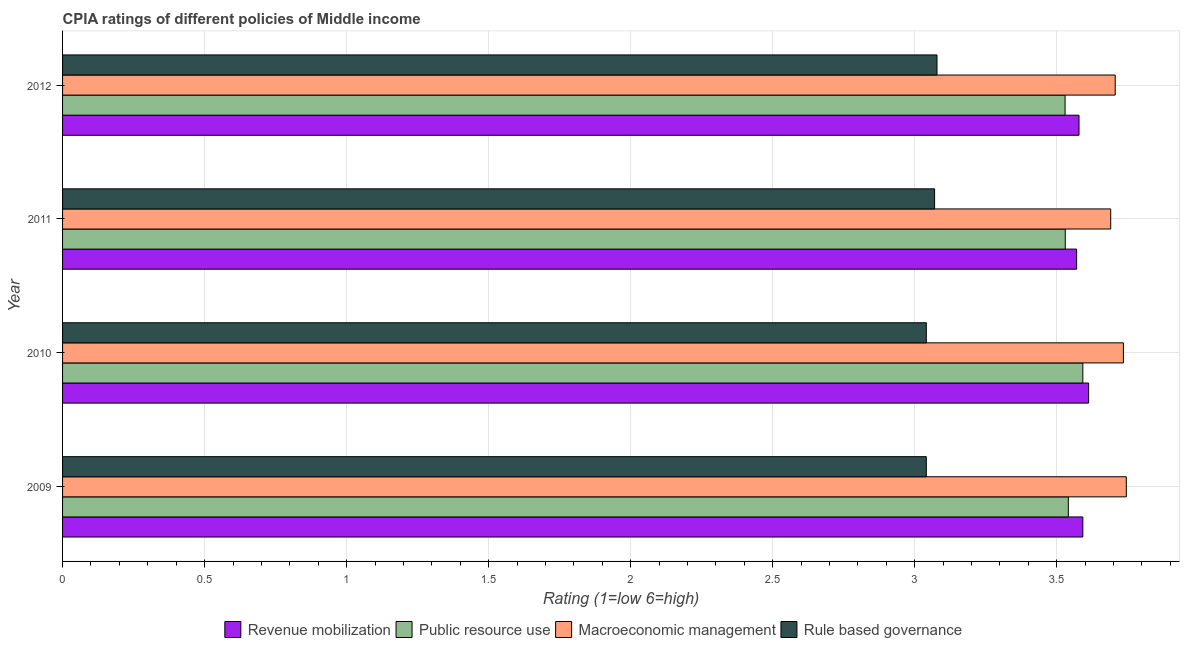How many different coloured bars are there?
Make the answer very short. 4. How many groups of bars are there?
Your answer should be very brief. 4. Are the number of bars per tick equal to the number of legend labels?
Make the answer very short. Yes. Are the number of bars on each tick of the Y-axis equal?
Offer a terse response. Yes. How many bars are there on the 1st tick from the top?
Your response must be concise. 4. In how many cases, is the number of bars for a given year not equal to the number of legend labels?
Offer a terse response. 0. What is the cpia rating of macroeconomic management in 2009?
Keep it short and to the point. 3.74. Across all years, what is the maximum cpia rating of rule based governance?
Keep it short and to the point. 3.08. Across all years, what is the minimum cpia rating of macroeconomic management?
Make the answer very short. 3.69. In which year was the cpia rating of rule based governance minimum?
Provide a succinct answer. 2009. What is the total cpia rating of rule based governance in the graph?
Provide a succinct answer. 12.23. What is the difference between the cpia rating of rule based governance in 2011 and that in 2012?
Give a very brief answer. -0.01. What is the difference between the cpia rating of rule based governance in 2012 and the cpia rating of revenue mobilization in 2011?
Provide a short and direct response. -0.49. What is the average cpia rating of public resource use per year?
Give a very brief answer. 3.55. In the year 2011, what is the difference between the cpia rating of public resource use and cpia rating of macroeconomic management?
Your answer should be very brief. -0.16. In how many years, is the cpia rating of rule based governance greater than 1.6 ?
Give a very brief answer. 4. What is the ratio of the cpia rating of revenue mobilization in 2009 to that in 2011?
Offer a terse response. 1.01. Is the cpia rating of public resource use in 2011 less than that in 2012?
Your response must be concise. No. What is the difference between the highest and the second highest cpia rating of public resource use?
Make the answer very short. 0.05. In how many years, is the cpia rating of rule based governance greater than the average cpia rating of rule based governance taken over all years?
Provide a short and direct response. 2. What does the 2nd bar from the top in 2012 represents?
Make the answer very short. Macroeconomic management. What does the 2nd bar from the bottom in 2012 represents?
Ensure brevity in your answer.  Public resource use. Is it the case that in every year, the sum of the cpia rating of revenue mobilization and cpia rating of public resource use is greater than the cpia rating of macroeconomic management?
Give a very brief answer. Yes. Are all the bars in the graph horizontal?
Provide a short and direct response. Yes. How many years are there in the graph?
Give a very brief answer. 4. What is the difference between two consecutive major ticks on the X-axis?
Provide a short and direct response. 0.5. Are the values on the major ticks of X-axis written in scientific E-notation?
Ensure brevity in your answer.  No. Does the graph contain any zero values?
Your answer should be very brief. No. Does the graph contain grids?
Ensure brevity in your answer.  Yes. What is the title of the graph?
Ensure brevity in your answer.  CPIA ratings of different policies of Middle income. What is the label or title of the X-axis?
Your answer should be very brief. Rating (1=low 6=high). What is the Rating (1=low 6=high) of Revenue mobilization in 2009?
Your response must be concise. 3.59. What is the Rating (1=low 6=high) in Public resource use in 2009?
Give a very brief answer. 3.54. What is the Rating (1=low 6=high) in Macroeconomic management in 2009?
Your answer should be very brief. 3.74. What is the Rating (1=low 6=high) in Rule based governance in 2009?
Provide a succinct answer. 3.04. What is the Rating (1=low 6=high) of Revenue mobilization in 2010?
Offer a terse response. 3.61. What is the Rating (1=low 6=high) of Public resource use in 2010?
Offer a very short reply. 3.59. What is the Rating (1=low 6=high) of Macroeconomic management in 2010?
Keep it short and to the point. 3.73. What is the Rating (1=low 6=high) of Rule based governance in 2010?
Provide a short and direct response. 3.04. What is the Rating (1=low 6=high) in Revenue mobilization in 2011?
Your answer should be very brief. 3.57. What is the Rating (1=low 6=high) in Public resource use in 2011?
Your response must be concise. 3.53. What is the Rating (1=low 6=high) of Macroeconomic management in 2011?
Offer a very short reply. 3.69. What is the Rating (1=low 6=high) in Rule based governance in 2011?
Offer a terse response. 3.07. What is the Rating (1=low 6=high) of Revenue mobilization in 2012?
Provide a succinct answer. 3.58. What is the Rating (1=low 6=high) in Public resource use in 2012?
Make the answer very short. 3.53. What is the Rating (1=low 6=high) of Macroeconomic management in 2012?
Give a very brief answer. 3.71. What is the Rating (1=low 6=high) of Rule based governance in 2012?
Your answer should be very brief. 3.08. Across all years, what is the maximum Rating (1=low 6=high) of Revenue mobilization?
Provide a short and direct response. 3.61. Across all years, what is the maximum Rating (1=low 6=high) in Public resource use?
Ensure brevity in your answer.  3.59. Across all years, what is the maximum Rating (1=low 6=high) of Macroeconomic management?
Offer a terse response. 3.74. Across all years, what is the maximum Rating (1=low 6=high) in Rule based governance?
Provide a short and direct response. 3.08. Across all years, what is the minimum Rating (1=low 6=high) of Revenue mobilization?
Keep it short and to the point. 3.57. Across all years, what is the minimum Rating (1=low 6=high) of Public resource use?
Your answer should be compact. 3.53. Across all years, what is the minimum Rating (1=low 6=high) of Macroeconomic management?
Offer a very short reply. 3.69. Across all years, what is the minimum Rating (1=low 6=high) of Rule based governance?
Ensure brevity in your answer.  3.04. What is the total Rating (1=low 6=high) of Revenue mobilization in the graph?
Your response must be concise. 14.35. What is the total Rating (1=low 6=high) of Public resource use in the graph?
Your answer should be very brief. 14.19. What is the total Rating (1=low 6=high) in Macroeconomic management in the graph?
Keep it short and to the point. 14.88. What is the total Rating (1=low 6=high) of Rule based governance in the graph?
Keep it short and to the point. 12.23. What is the difference between the Rating (1=low 6=high) in Revenue mobilization in 2009 and that in 2010?
Keep it short and to the point. -0.02. What is the difference between the Rating (1=low 6=high) of Public resource use in 2009 and that in 2010?
Your response must be concise. -0.05. What is the difference between the Rating (1=low 6=high) of Macroeconomic management in 2009 and that in 2010?
Ensure brevity in your answer.  0.01. What is the difference between the Rating (1=low 6=high) of Revenue mobilization in 2009 and that in 2011?
Give a very brief answer. 0.02. What is the difference between the Rating (1=low 6=high) in Public resource use in 2009 and that in 2011?
Ensure brevity in your answer.  0.01. What is the difference between the Rating (1=low 6=high) in Macroeconomic management in 2009 and that in 2011?
Your answer should be very brief. 0.05. What is the difference between the Rating (1=low 6=high) in Rule based governance in 2009 and that in 2011?
Provide a succinct answer. -0.03. What is the difference between the Rating (1=low 6=high) in Revenue mobilization in 2009 and that in 2012?
Your answer should be compact. 0.01. What is the difference between the Rating (1=low 6=high) in Public resource use in 2009 and that in 2012?
Provide a short and direct response. 0.01. What is the difference between the Rating (1=low 6=high) in Macroeconomic management in 2009 and that in 2012?
Make the answer very short. 0.04. What is the difference between the Rating (1=low 6=high) in Rule based governance in 2009 and that in 2012?
Keep it short and to the point. -0.04. What is the difference between the Rating (1=low 6=high) in Revenue mobilization in 2010 and that in 2011?
Make the answer very short. 0.04. What is the difference between the Rating (1=low 6=high) in Public resource use in 2010 and that in 2011?
Give a very brief answer. 0.06. What is the difference between the Rating (1=low 6=high) in Macroeconomic management in 2010 and that in 2011?
Offer a very short reply. 0.04. What is the difference between the Rating (1=low 6=high) in Rule based governance in 2010 and that in 2011?
Offer a very short reply. -0.03. What is the difference between the Rating (1=low 6=high) in Revenue mobilization in 2010 and that in 2012?
Ensure brevity in your answer.  0.03. What is the difference between the Rating (1=low 6=high) in Public resource use in 2010 and that in 2012?
Ensure brevity in your answer.  0.06. What is the difference between the Rating (1=low 6=high) in Macroeconomic management in 2010 and that in 2012?
Make the answer very short. 0.03. What is the difference between the Rating (1=low 6=high) of Rule based governance in 2010 and that in 2012?
Your answer should be compact. -0.04. What is the difference between the Rating (1=low 6=high) of Revenue mobilization in 2011 and that in 2012?
Offer a terse response. -0.01. What is the difference between the Rating (1=low 6=high) of Public resource use in 2011 and that in 2012?
Your answer should be very brief. 0. What is the difference between the Rating (1=low 6=high) of Macroeconomic management in 2011 and that in 2012?
Provide a short and direct response. -0.02. What is the difference between the Rating (1=low 6=high) of Rule based governance in 2011 and that in 2012?
Provide a short and direct response. -0.01. What is the difference between the Rating (1=low 6=high) of Revenue mobilization in 2009 and the Rating (1=low 6=high) of Public resource use in 2010?
Make the answer very short. 0. What is the difference between the Rating (1=low 6=high) of Revenue mobilization in 2009 and the Rating (1=low 6=high) of Macroeconomic management in 2010?
Your answer should be compact. -0.14. What is the difference between the Rating (1=low 6=high) of Revenue mobilization in 2009 and the Rating (1=low 6=high) of Rule based governance in 2010?
Provide a succinct answer. 0.55. What is the difference between the Rating (1=low 6=high) of Public resource use in 2009 and the Rating (1=low 6=high) of Macroeconomic management in 2010?
Ensure brevity in your answer.  -0.19. What is the difference between the Rating (1=low 6=high) of Public resource use in 2009 and the Rating (1=low 6=high) of Rule based governance in 2010?
Your answer should be compact. 0.5. What is the difference between the Rating (1=low 6=high) in Macroeconomic management in 2009 and the Rating (1=low 6=high) in Rule based governance in 2010?
Provide a succinct answer. 0.7. What is the difference between the Rating (1=low 6=high) of Revenue mobilization in 2009 and the Rating (1=low 6=high) of Public resource use in 2011?
Provide a succinct answer. 0.06. What is the difference between the Rating (1=low 6=high) of Revenue mobilization in 2009 and the Rating (1=low 6=high) of Macroeconomic management in 2011?
Make the answer very short. -0.1. What is the difference between the Rating (1=low 6=high) of Revenue mobilization in 2009 and the Rating (1=low 6=high) of Rule based governance in 2011?
Provide a short and direct response. 0.52. What is the difference between the Rating (1=low 6=high) of Public resource use in 2009 and the Rating (1=low 6=high) of Macroeconomic management in 2011?
Provide a succinct answer. -0.15. What is the difference between the Rating (1=low 6=high) in Public resource use in 2009 and the Rating (1=low 6=high) in Rule based governance in 2011?
Keep it short and to the point. 0.47. What is the difference between the Rating (1=low 6=high) of Macroeconomic management in 2009 and the Rating (1=low 6=high) of Rule based governance in 2011?
Offer a terse response. 0.67. What is the difference between the Rating (1=low 6=high) of Revenue mobilization in 2009 and the Rating (1=low 6=high) of Public resource use in 2012?
Offer a terse response. 0.06. What is the difference between the Rating (1=low 6=high) in Revenue mobilization in 2009 and the Rating (1=low 6=high) in Macroeconomic management in 2012?
Your answer should be very brief. -0.11. What is the difference between the Rating (1=low 6=high) in Revenue mobilization in 2009 and the Rating (1=low 6=high) in Rule based governance in 2012?
Offer a very short reply. 0.51. What is the difference between the Rating (1=low 6=high) in Public resource use in 2009 and the Rating (1=low 6=high) in Macroeconomic management in 2012?
Your answer should be compact. -0.17. What is the difference between the Rating (1=low 6=high) of Public resource use in 2009 and the Rating (1=low 6=high) of Rule based governance in 2012?
Provide a short and direct response. 0.46. What is the difference between the Rating (1=low 6=high) in Macroeconomic management in 2009 and the Rating (1=low 6=high) in Rule based governance in 2012?
Provide a succinct answer. 0.67. What is the difference between the Rating (1=low 6=high) of Revenue mobilization in 2010 and the Rating (1=low 6=high) of Public resource use in 2011?
Your response must be concise. 0.08. What is the difference between the Rating (1=low 6=high) in Revenue mobilization in 2010 and the Rating (1=low 6=high) in Macroeconomic management in 2011?
Your answer should be compact. -0.08. What is the difference between the Rating (1=low 6=high) in Revenue mobilization in 2010 and the Rating (1=low 6=high) in Rule based governance in 2011?
Your answer should be very brief. 0.54. What is the difference between the Rating (1=low 6=high) in Public resource use in 2010 and the Rating (1=low 6=high) in Macroeconomic management in 2011?
Ensure brevity in your answer.  -0.1. What is the difference between the Rating (1=low 6=high) of Public resource use in 2010 and the Rating (1=low 6=high) of Rule based governance in 2011?
Provide a succinct answer. 0.52. What is the difference between the Rating (1=low 6=high) of Macroeconomic management in 2010 and the Rating (1=low 6=high) of Rule based governance in 2011?
Your answer should be compact. 0.66. What is the difference between the Rating (1=low 6=high) of Revenue mobilization in 2010 and the Rating (1=low 6=high) of Public resource use in 2012?
Offer a terse response. 0.08. What is the difference between the Rating (1=low 6=high) of Revenue mobilization in 2010 and the Rating (1=low 6=high) of Macroeconomic management in 2012?
Provide a short and direct response. -0.09. What is the difference between the Rating (1=low 6=high) in Revenue mobilization in 2010 and the Rating (1=low 6=high) in Rule based governance in 2012?
Provide a short and direct response. 0.53. What is the difference between the Rating (1=low 6=high) of Public resource use in 2010 and the Rating (1=low 6=high) of Macroeconomic management in 2012?
Your answer should be very brief. -0.11. What is the difference between the Rating (1=low 6=high) of Public resource use in 2010 and the Rating (1=low 6=high) of Rule based governance in 2012?
Provide a short and direct response. 0.51. What is the difference between the Rating (1=low 6=high) of Macroeconomic management in 2010 and the Rating (1=low 6=high) of Rule based governance in 2012?
Provide a short and direct response. 0.66. What is the difference between the Rating (1=low 6=high) in Revenue mobilization in 2011 and the Rating (1=low 6=high) in Public resource use in 2012?
Make the answer very short. 0.04. What is the difference between the Rating (1=low 6=high) in Revenue mobilization in 2011 and the Rating (1=low 6=high) in Macroeconomic management in 2012?
Ensure brevity in your answer.  -0.14. What is the difference between the Rating (1=low 6=high) of Revenue mobilization in 2011 and the Rating (1=low 6=high) of Rule based governance in 2012?
Your response must be concise. 0.49. What is the difference between the Rating (1=low 6=high) of Public resource use in 2011 and the Rating (1=low 6=high) of Macroeconomic management in 2012?
Offer a terse response. -0.18. What is the difference between the Rating (1=low 6=high) of Public resource use in 2011 and the Rating (1=low 6=high) of Rule based governance in 2012?
Your response must be concise. 0.45. What is the difference between the Rating (1=low 6=high) of Macroeconomic management in 2011 and the Rating (1=low 6=high) of Rule based governance in 2012?
Offer a very short reply. 0.61. What is the average Rating (1=low 6=high) of Revenue mobilization per year?
Provide a short and direct response. 3.59. What is the average Rating (1=low 6=high) of Public resource use per year?
Keep it short and to the point. 3.55. What is the average Rating (1=low 6=high) in Macroeconomic management per year?
Your answer should be very brief. 3.72. What is the average Rating (1=low 6=high) of Rule based governance per year?
Offer a terse response. 3.06. In the year 2009, what is the difference between the Rating (1=low 6=high) in Revenue mobilization and Rating (1=low 6=high) in Public resource use?
Make the answer very short. 0.05. In the year 2009, what is the difference between the Rating (1=low 6=high) in Revenue mobilization and Rating (1=low 6=high) in Macroeconomic management?
Offer a very short reply. -0.15. In the year 2009, what is the difference between the Rating (1=low 6=high) in Revenue mobilization and Rating (1=low 6=high) in Rule based governance?
Give a very brief answer. 0.55. In the year 2009, what is the difference between the Rating (1=low 6=high) of Public resource use and Rating (1=low 6=high) of Macroeconomic management?
Offer a terse response. -0.2. In the year 2009, what is the difference between the Rating (1=low 6=high) in Macroeconomic management and Rating (1=low 6=high) in Rule based governance?
Offer a very short reply. 0.7. In the year 2010, what is the difference between the Rating (1=low 6=high) of Revenue mobilization and Rating (1=low 6=high) of Public resource use?
Your response must be concise. 0.02. In the year 2010, what is the difference between the Rating (1=low 6=high) of Revenue mobilization and Rating (1=low 6=high) of Macroeconomic management?
Your response must be concise. -0.12. In the year 2010, what is the difference between the Rating (1=low 6=high) of Revenue mobilization and Rating (1=low 6=high) of Rule based governance?
Offer a very short reply. 0.57. In the year 2010, what is the difference between the Rating (1=low 6=high) of Public resource use and Rating (1=low 6=high) of Macroeconomic management?
Your answer should be compact. -0.14. In the year 2010, what is the difference between the Rating (1=low 6=high) in Public resource use and Rating (1=low 6=high) in Rule based governance?
Keep it short and to the point. 0.55. In the year 2010, what is the difference between the Rating (1=low 6=high) in Macroeconomic management and Rating (1=low 6=high) in Rule based governance?
Provide a succinct answer. 0.69. In the year 2011, what is the difference between the Rating (1=low 6=high) in Revenue mobilization and Rating (1=low 6=high) in Public resource use?
Provide a short and direct response. 0.04. In the year 2011, what is the difference between the Rating (1=low 6=high) in Revenue mobilization and Rating (1=low 6=high) in Macroeconomic management?
Your response must be concise. -0.12. In the year 2011, what is the difference between the Rating (1=low 6=high) of Revenue mobilization and Rating (1=low 6=high) of Rule based governance?
Your answer should be very brief. 0.5. In the year 2011, what is the difference between the Rating (1=low 6=high) of Public resource use and Rating (1=low 6=high) of Macroeconomic management?
Offer a terse response. -0.16. In the year 2011, what is the difference between the Rating (1=low 6=high) in Public resource use and Rating (1=low 6=high) in Rule based governance?
Offer a very short reply. 0.46. In the year 2011, what is the difference between the Rating (1=low 6=high) in Macroeconomic management and Rating (1=low 6=high) in Rule based governance?
Give a very brief answer. 0.62. In the year 2012, what is the difference between the Rating (1=low 6=high) of Revenue mobilization and Rating (1=low 6=high) of Public resource use?
Give a very brief answer. 0.05. In the year 2012, what is the difference between the Rating (1=low 6=high) in Revenue mobilization and Rating (1=low 6=high) in Macroeconomic management?
Make the answer very short. -0.13. In the year 2012, what is the difference between the Rating (1=low 6=high) in Public resource use and Rating (1=low 6=high) in Macroeconomic management?
Provide a short and direct response. -0.18. In the year 2012, what is the difference between the Rating (1=low 6=high) of Public resource use and Rating (1=low 6=high) of Rule based governance?
Provide a succinct answer. 0.45. In the year 2012, what is the difference between the Rating (1=low 6=high) in Macroeconomic management and Rating (1=low 6=high) in Rule based governance?
Give a very brief answer. 0.63. What is the ratio of the Rating (1=low 6=high) of Revenue mobilization in 2009 to that in 2010?
Ensure brevity in your answer.  0.99. What is the ratio of the Rating (1=low 6=high) in Public resource use in 2009 to that in 2010?
Ensure brevity in your answer.  0.99. What is the ratio of the Rating (1=low 6=high) in Rule based governance in 2009 to that in 2010?
Your answer should be compact. 1. What is the ratio of the Rating (1=low 6=high) of Public resource use in 2009 to that in 2011?
Keep it short and to the point. 1. What is the ratio of the Rating (1=low 6=high) of Macroeconomic management in 2009 to that in 2011?
Provide a short and direct response. 1.01. What is the ratio of the Rating (1=low 6=high) in Rule based governance in 2009 to that in 2011?
Provide a short and direct response. 0.99. What is the ratio of the Rating (1=low 6=high) of Revenue mobilization in 2009 to that in 2012?
Ensure brevity in your answer.  1. What is the ratio of the Rating (1=low 6=high) of Public resource use in 2009 to that in 2012?
Your response must be concise. 1. What is the ratio of the Rating (1=low 6=high) of Macroeconomic management in 2009 to that in 2012?
Provide a succinct answer. 1.01. What is the ratio of the Rating (1=low 6=high) of Revenue mobilization in 2010 to that in 2011?
Offer a very short reply. 1.01. What is the ratio of the Rating (1=low 6=high) of Public resource use in 2010 to that in 2011?
Keep it short and to the point. 1.02. What is the ratio of the Rating (1=low 6=high) in Macroeconomic management in 2010 to that in 2011?
Offer a terse response. 1.01. What is the ratio of the Rating (1=low 6=high) in Revenue mobilization in 2010 to that in 2012?
Give a very brief answer. 1.01. What is the ratio of the Rating (1=low 6=high) of Public resource use in 2010 to that in 2012?
Offer a terse response. 1.02. What is the ratio of the Rating (1=low 6=high) in Public resource use in 2011 to that in 2012?
Offer a terse response. 1. What is the difference between the highest and the second highest Rating (1=low 6=high) in Revenue mobilization?
Offer a very short reply. 0.02. What is the difference between the highest and the second highest Rating (1=low 6=high) of Public resource use?
Ensure brevity in your answer.  0.05. What is the difference between the highest and the second highest Rating (1=low 6=high) of Macroeconomic management?
Your answer should be compact. 0.01. What is the difference between the highest and the second highest Rating (1=low 6=high) in Rule based governance?
Your response must be concise. 0.01. What is the difference between the highest and the lowest Rating (1=low 6=high) of Revenue mobilization?
Offer a very short reply. 0.04. What is the difference between the highest and the lowest Rating (1=low 6=high) of Public resource use?
Your answer should be compact. 0.06. What is the difference between the highest and the lowest Rating (1=low 6=high) in Macroeconomic management?
Provide a short and direct response. 0.05. What is the difference between the highest and the lowest Rating (1=low 6=high) in Rule based governance?
Offer a very short reply. 0.04. 